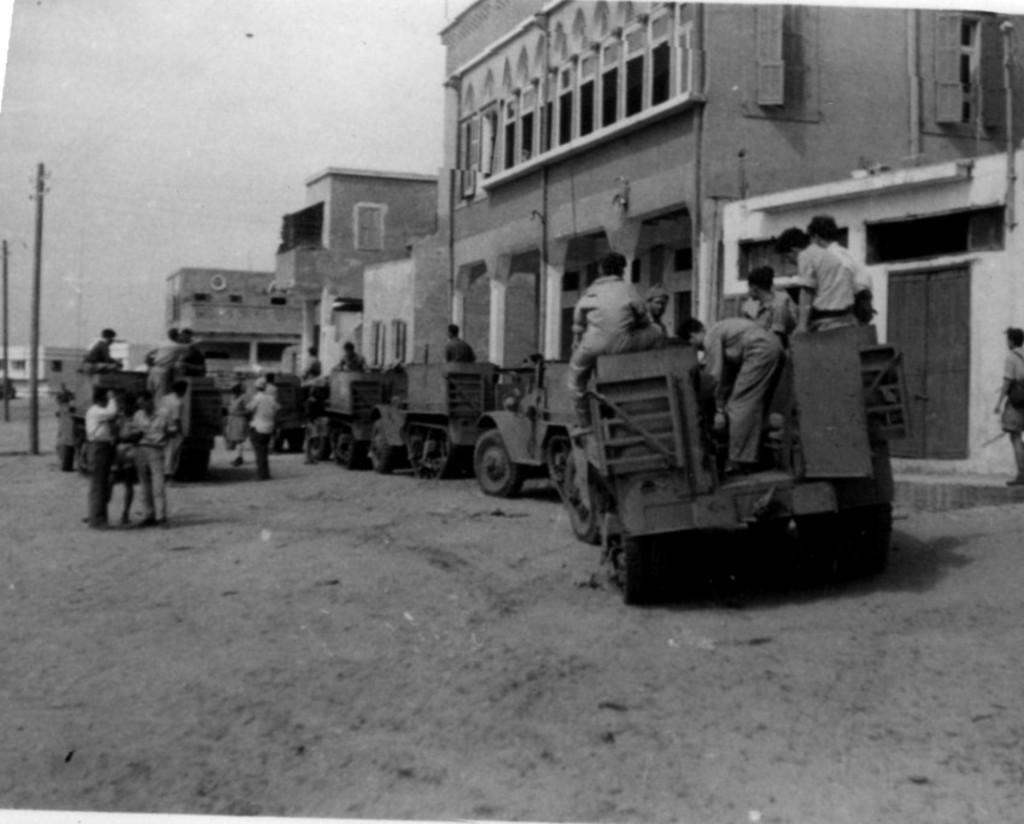Describe this image in one or two sentences. In this picture I can see some people were sitting on this truck and other vehicles. On the left I can see a group of persons who are standing near to the truck, beside that I can see the electric poles and wires are connected to it. On the right I can see the buildings. In the top left I can see the sky. 